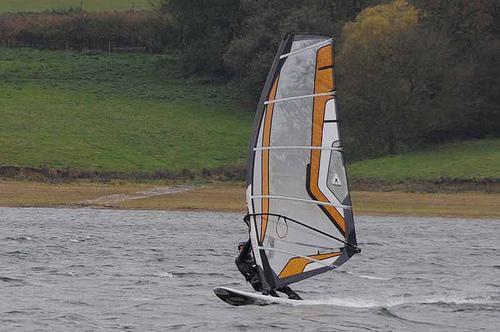How many people?
Give a very brief answer. 1. 